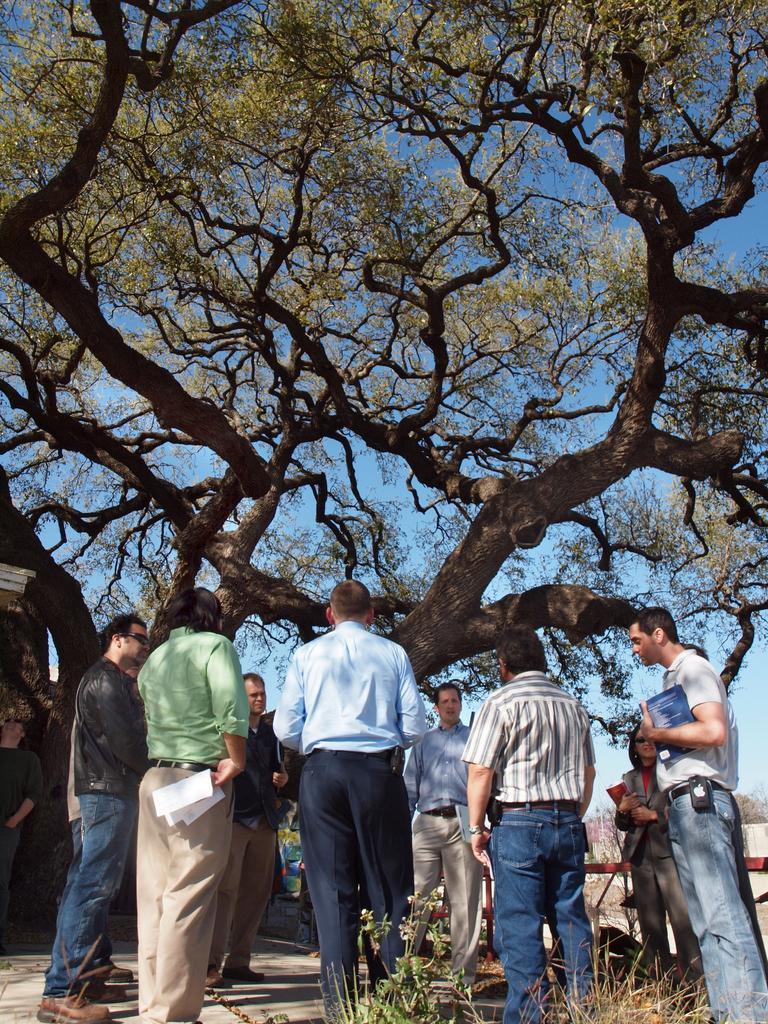Can you describe this image briefly? At the bottom of the picture, we see the plants and the road. In this picture, we see the group of people are standing. They are holding books, paper and water bottles in their hands. Behind them, we see a tree. In the background, we see the sky. 